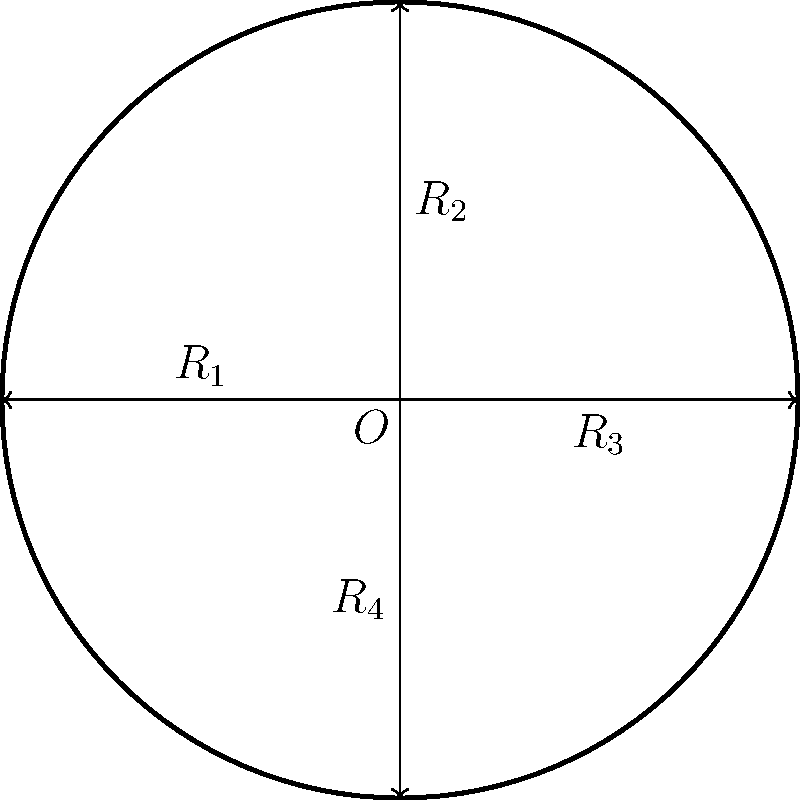Consider the rotation group of an SUV's wheel, represented by the diagram. The wheel can be rotated by 90° clockwise four times to complete a full 360° rotation. Let $R_1$, $R_2$, $R_3$, and $R_4$ represent these 90° rotations as shown. If we apply rotation $R_2$ followed by rotation $R_4$, which single rotation would produce the same result? Let's approach this step-by-step:

1) First, recall that the rotation group of a square (which is isomorphic to the rotation group of the wheel) is the cyclic group $C_4$.

2) $R_2$ represents a 90° counterclockwise rotation (or 270° clockwise).
3) $R_4$ represents a 270° counterclockwise rotation (or 90° clockwise).

4) Applying $R_2$ followed by $R_4$ is equivalent to:
   270° clockwise + 90° clockwise = 360° clockwise

5) A 360° clockwise rotation brings the wheel back to its original position.

6) In group theory, this is represented by the identity element, which in this case is $R_1 \circ R_1 \circ R_1 \circ R_1$ (four 90° rotations), or simply $R_1^4$.

7) However, the question asks for a single rotation that produces the same result.

8) The rotation that leaves the wheel unchanged is the identity rotation, which is equivalent to $R_1^4$, or no rotation at all.

Therefore, the single rotation that produces the same result as $R_2$ followed by $R_4$ is the identity rotation, which can be represented by $R_1^4$ or simply as the identity element $e$ in group theory notation.
Answer: $R_1^4$ or $e$ (identity element) 